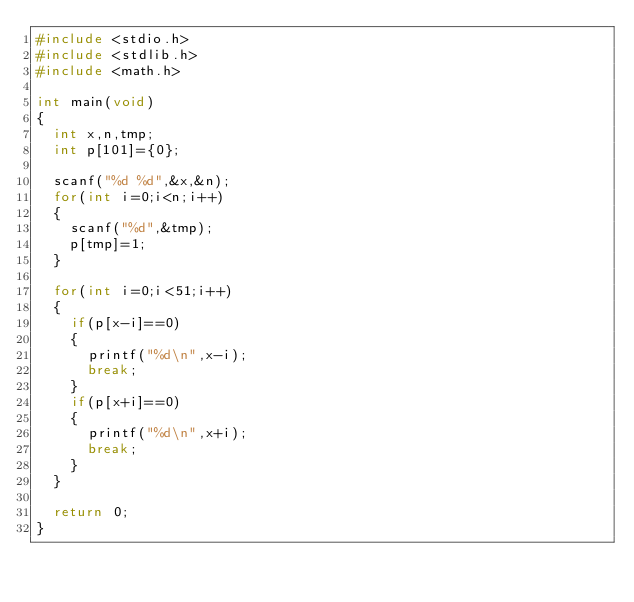<code> <loc_0><loc_0><loc_500><loc_500><_C_>#include <stdio.h>
#include <stdlib.h>
#include <math.h>

int main(void)
{
  int x,n,tmp;
  int p[101]={0};

  scanf("%d %d",&x,&n);
  for(int i=0;i<n;i++)
  {
    scanf("%d",&tmp);
    p[tmp]=1;
  }

  for(int i=0;i<51;i++)
  {
    if(p[x-i]==0)
    {
      printf("%d\n",x-i);
      break;
    }
    if(p[x+i]==0)
    {
      printf("%d\n",x+i);
      break;
    }
  }

  return 0;
}</code> 